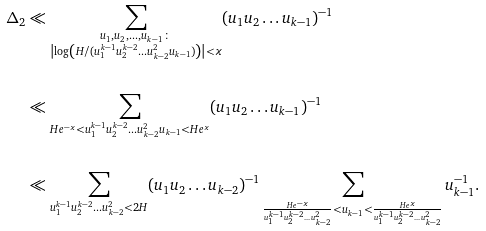Convert formula to latex. <formula><loc_0><loc_0><loc_500><loc_500>\Delta _ { 2 } & \ll \sum _ { \substack { u _ { 1 } , u _ { 2 } , \dots , u _ { k - 1 } \, \colon \\ \left | \log \left ( H / ( u _ { 1 } ^ { k - 1 } u _ { 2 } ^ { k - 2 } \dots u _ { k - 2 } ^ { 2 } u _ { k - 1 } ) \right ) \right | < \varkappa } } ( u _ { 1 } u _ { 2 } \dots u _ { k - 1 } ) ^ { - 1 } & \\ \\ & \ll \sum _ { H e ^ { - \varkappa } < u _ { 1 } ^ { k - 1 } u _ { 2 } ^ { k - 2 } \dots u _ { k - 2 } ^ { 2 } u _ { k - 1 } < H e ^ { \varkappa } } ( u _ { 1 } u _ { 2 } \dots u _ { k - 1 } ) ^ { - 1 } & \\ \\ & \ll \sum _ { u _ { 1 } ^ { k - 1 } u _ { 2 } ^ { k - 2 } \dots u _ { k - 2 } ^ { 2 } < 2 H } ( u _ { 1 } u _ { 2 } \dots u _ { k - 2 } ) ^ { - 1 } \sum _ { \frac { H e ^ { - \varkappa } } { u _ { 1 } ^ { k - 1 } u _ { 2 } ^ { k - 2 } \dots u _ { k - 2 } ^ { 2 } } < u _ { k - 1 } < \frac { H e ^ { \varkappa } } { u _ { 1 } ^ { k - 1 } u _ { 2 } ^ { k - 2 } \dots u _ { k - 2 } ^ { 2 } } } u _ { k - 1 } ^ { - 1 } .</formula> 